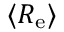<formula> <loc_0><loc_0><loc_500><loc_500>\langle R _ { e } \rangle</formula> 